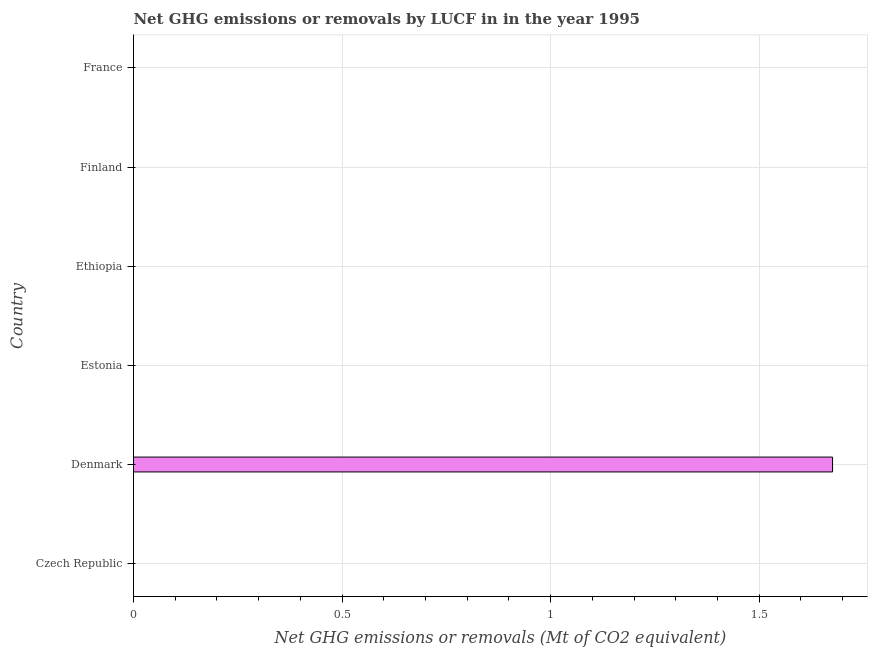Does the graph contain any zero values?
Provide a short and direct response. Yes. Does the graph contain grids?
Give a very brief answer. Yes. What is the title of the graph?
Make the answer very short. Net GHG emissions or removals by LUCF in in the year 1995. What is the label or title of the X-axis?
Offer a terse response. Net GHG emissions or removals (Mt of CO2 equivalent). What is the label or title of the Y-axis?
Your response must be concise. Country. What is the ghg net emissions or removals in Finland?
Provide a succinct answer. 0. Across all countries, what is the maximum ghg net emissions or removals?
Provide a succinct answer. 1.68. What is the sum of the ghg net emissions or removals?
Your response must be concise. 1.68. What is the average ghg net emissions or removals per country?
Your response must be concise. 0.28. What is the median ghg net emissions or removals?
Give a very brief answer. 0. In how many countries, is the ghg net emissions or removals greater than 1.4 Mt?
Your answer should be compact. 1. What is the difference between the highest and the lowest ghg net emissions or removals?
Provide a short and direct response. 1.68. In how many countries, is the ghg net emissions or removals greater than the average ghg net emissions or removals taken over all countries?
Ensure brevity in your answer.  1. Are all the bars in the graph horizontal?
Make the answer very short. Yes. How many countries are there in the graph?
Offer a very short reply. 6. What is the Net GHG emissions or removals (Mt of CO2 equivalent) of Denmark?
Your answer should be compact. 1.68. 